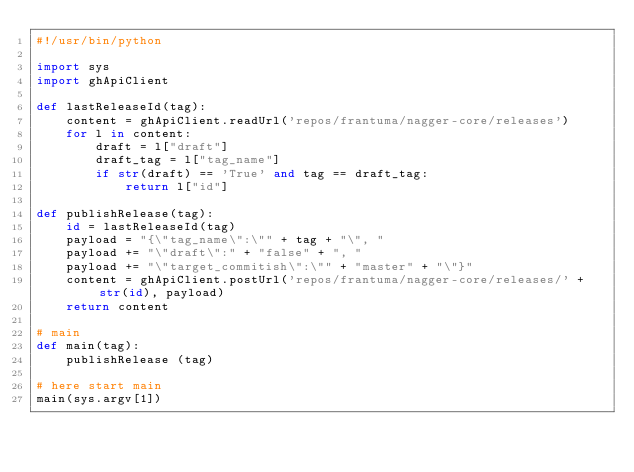Convert code to text. <code><loc_0><loc_0><loc_500><loc_500><_Python_>#!/usr/bin/python

import sys
import ghApiClient

def lastReleaseId(tag):
    content = ghApiClient.readUrl('repos/frantuma/nagger-core/releases')
    for l in content:
        draft = l["draft"]
        draft_tag = l["tag_name"]
        if str(draft) == 'True' and tag == draft_tag:
            return l["id"]

def publishRelease(tag):
    id = lastReleaseId(tag)
    payload = "{\"tag_name\":\"" + tag + "\", "
    payload += "\"draft\":" + "false" + ", "
    payload += "\"target_commitish\":\"" + "master" + "\"}"
    content = ghApiClient.postUrl('repos/frantuma/nagger-core/releases/' + str(id), payload)
    return content

# main
def main(tag):
    publishRelease (tag)

# here start main
main(sys.argv[1])
</code> 